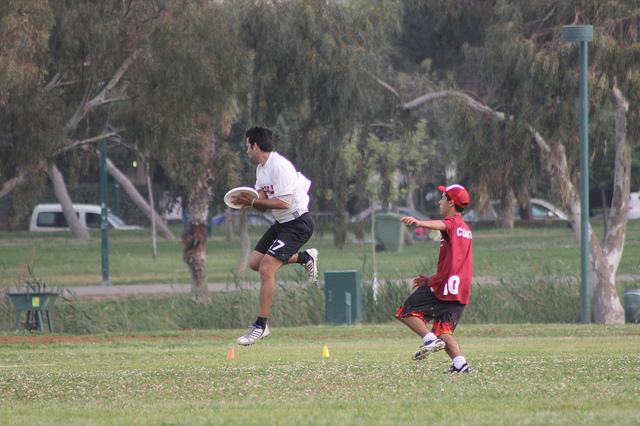What number is on the red shirt?
Give a very brief answer. 10. How many flags?
Short answer required. 0. Are either of the men wearing green?
Concise answer only. No. How many feet are on the ground?
Keep it brief. 1. 